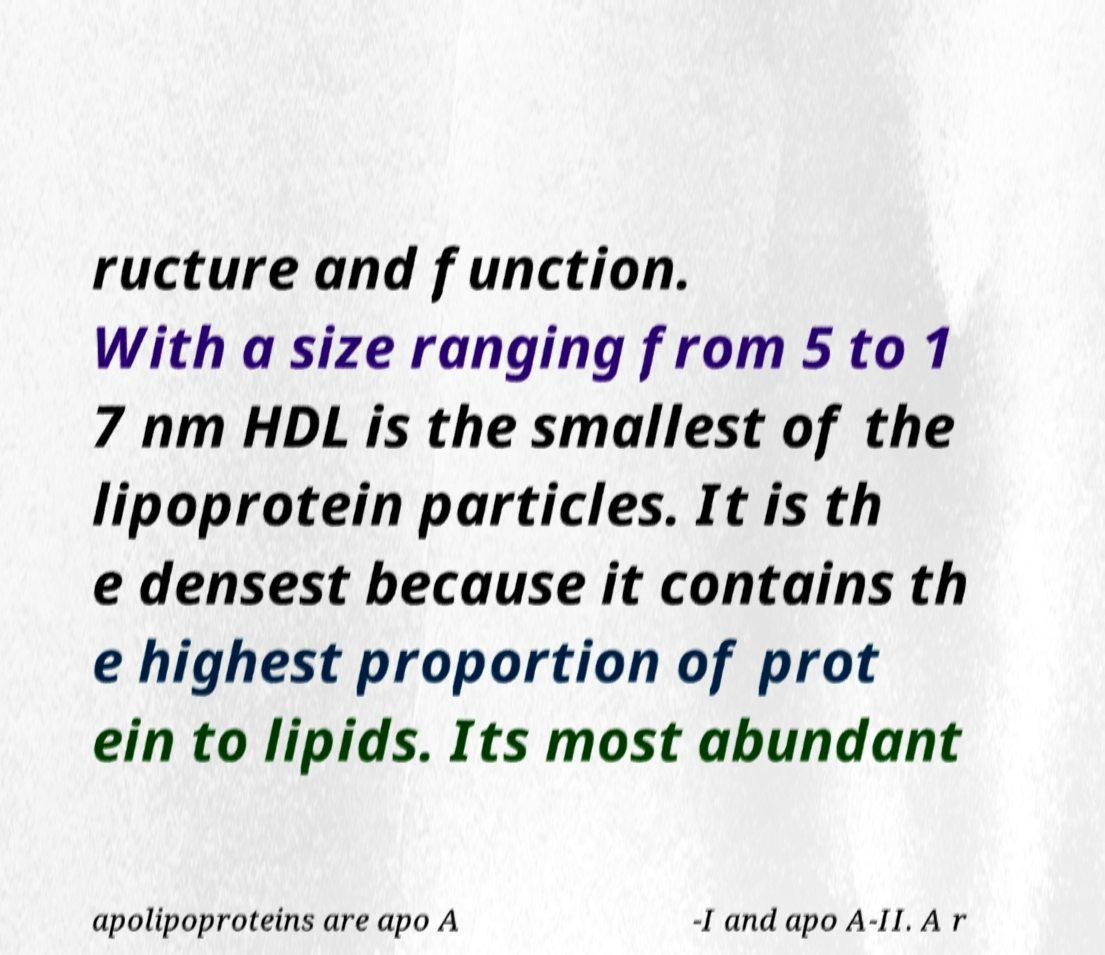Could you extract and type out the text from this image? ructure and function. With a size ranging from 5 to 1 7 nm HDL is the smallest of the lipoprotein particles. It is th e densest because it contains th e highest proportion of prot ein to lipids. Its most abundant apolipoproteins are apo A -I and apo A-II. A r 